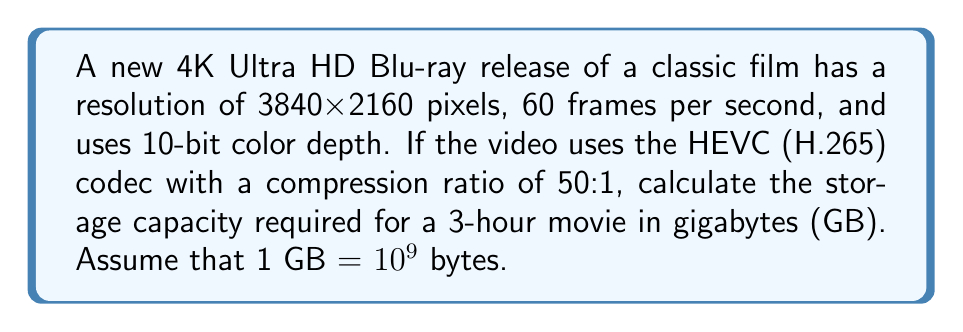Can you solve this math problem? Let's break this down step-by-step:

1) First, calculate the uncompressed data rate:
   - Resolution: 3840 x 2160 = 8,294,400 pixels per frame
   - Color depth: 10 bits per channel, 3 channels (RGB) = 30 bits per pixel
   - Frame rate: 60 fps

   Uncompressed data rate = $8,294,400 \times 30 \times 60 = 14,929,920,000$ bits/second

2) Convert bits to bytes:
   $14,929,920,000 \div 8 = 1,866,240,000$ bytes/second

3) Calculate for 3 hours:
   $1,866,240,000 \times 3600 \times 3 = 20,155,392,000,000$ bytes

4) Apply the compression ratio of 50:1:
   $20,155,392,000,000 \div 50 = 403,107,840,000$ bytes

5) Convert to gigabytes:
   $403,107,840,000 \div 10^9 = 403.1078400$ GB

Therefore, the storage capacity required is approximately 403.11 GB.
Answer: 403.11 GB 